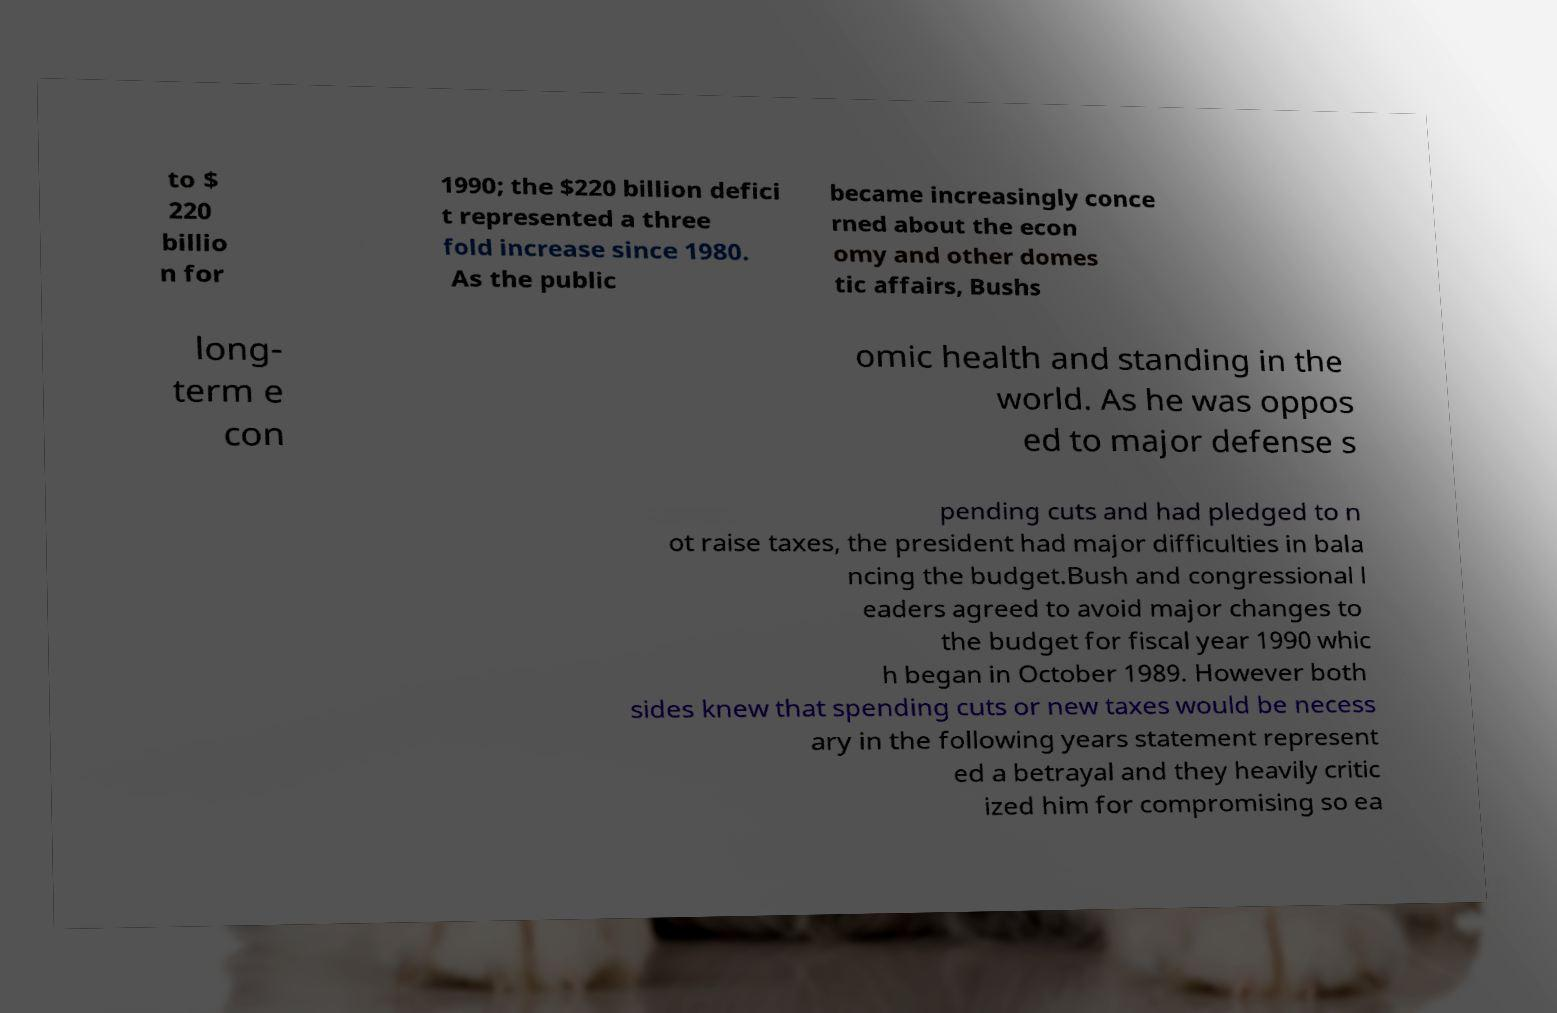Can you accurately transcribe the text from the provided image for me? to $ 220 billio n for 1990; the $220 billion defici t represented a three fold increase since 1980. As the public became increasingly conce rned about the econ omy and other domes tic affairs, Bushs long- term e con omic health and standing in the world. As he was oppos ed to major defense s pending cuts and had pledged to n ot raise taxes, the president had major difficulties in bala ncing the budget.Bush and congressional l eaders agreed to avoid major changes to the budget for fiscal year 1990 whic h began in October 1989. However both sides knew that spending cuts or new taxes would be necess ary in the following years statement represent ed a betrayal and they heavily critic ized him for compromising so ea 